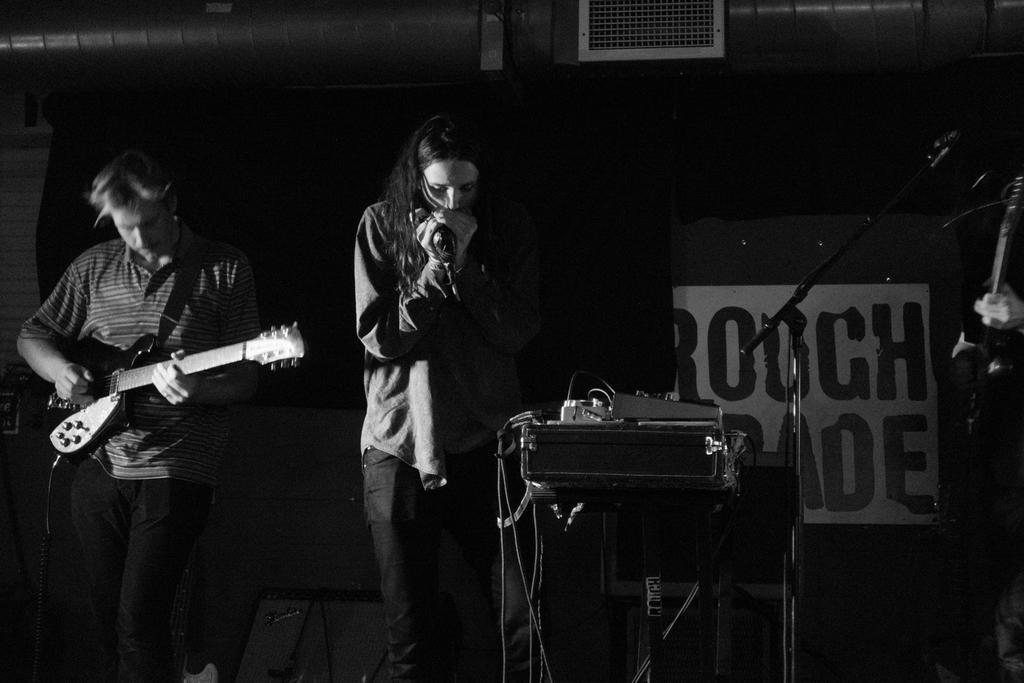Please provide a concise description of this image. In this image on the left side there are two persons who are standing in the middle, the person who is standing is holding a mike it seems that he is singing. On the left side one man is standing and he is holding a guitar in the middle there are some sound systems on the background there is a wall. 